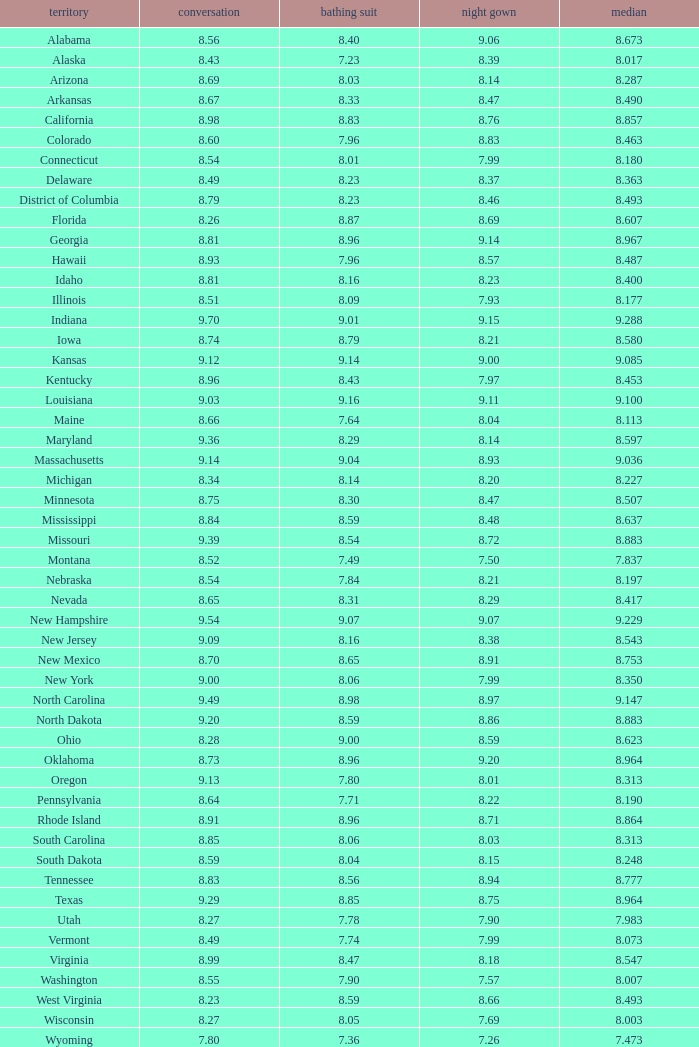Could you parse the entire table as a dict? {'header': ['territory', 'conversation', 'bathing suit', 'night gown', 'median'], 'rows': [['Alabama', '8.56', '8.40', '9.06', '8.673'], ['Alaska', '8.43', '7.23', '8.39', '8.017'], ['Arizona', '8.69', '8.03', '8.14', '8.287'], ['Arkansas', '8.67', '8.33', '8.47', '8.490'], ['California', '8.98', '8.83', '8.76', '8.857'], ['Colorado', '8.60', '7.96', '8.83', '8.463'], ['Connecticut', '8.54', '8.01', '7.99', '8.180'], ['Delaware', '8.49', '8.23', '8.37', '8.363'], ['District of Columbia', '8.79', '8.23', '8.46', '8.493'], ['Florida', '8.26', '8.87', '8.69', '8.607'], ['Georgia', '8.81', '8.96', '9.14', '8.967'], ['Hawaii', '8.93', '7.96', '8.57', '8.487'], ['Idaho', '8.81', '8.16', '8.23', '8.400'], ['Illinois', '8.51', '8.09', '7.93', '8.177'], ['Indiana', '9.70', '9.01', '9.15', '9.288'], ['Iowa', '8.74', '8.79', '8.21', '8.580'], ['Kansas', '9.12', '9.14', '9.00', '9.085'], ['Kentucky', '8.96', '8.43', '7.97', '8.453'], ['Louisiana', '9.03', '9.16', '9.11', '9.100'], ['Maine', '8.66', '7.64', '8.04', '8.113'], ['Maryland', '9.36', '8.29', '8.14', '8.597'], ['Massachusetts', '9.14', '9.04', '8.93', '9.036'], ['Michigan', '8.34', '8.14', '8.20', '8.227'], ['Minnesota', '8.75', '8.30', '8.47', '8.507'], ['Mississippi', '8.84', '8.59', '8.48', '8.637'], ['Missouri', '9.39', '8.54', '8.72', '8.883'], ['Montana', '8.52', '7.49', '7.50', '7.837'], ['Nebraska', '8.54', '7.84', '8.21', '8.197'], ['Nevada', '8.65', '8.31', '8.29', '8.417'], ['New Hampshire', '9.54', '9.07', '9.07', '9.229'], ['New Jersey', '9.09', '8.16', '8.38', '8.543'], ['New Mexico', '8.70', '8.65', '8.91', '8.753'], ['New York', '9.00', '8.06', '7.99', '8.350'], ['North Carolina', '9.49', '8.98', '8.97', '9.147'], ['North Dakota', '9.20', '8.59', '8.86', '8.883'], ['Ohio', '8.28', '9.00', '8.59', '8.623'], ['Oklahoma', '8.73', '8.96', '9.20', '8.964'], ['Oregon', '9.13', '7.80', '8.01', '8.313'], ['Pennsylvania', '8.64', '7.71', '8.22', '8.190'], ['Rhode Island', '8.91', '8.96', '8.71', '8.864'], ['South Carolina', '8.85', '8.06', '8.03', '8.313'], ['South Dakota', '8.59', '8.04', '8.15', '8.248'], ['Tennessee', '8.83', '8.56', '8.94', '8.777'], ['Texas', '9.29', '8.85', '8.75', '8.964'], ['Utah', '8.27', '7.78', '7.90', '7.983'], ['Vermont', '8.49', '7.74', '7.99', '8.073'], ['Virginia', '8.99', '8.47', '8.18', '8.547'], ['Washington', '8.55', '7.90', '7.57', '8.007'], ['West Virginia', '8.23', '8.59', '8.66', '8.493'], ['Wisconsin', '8.27', '8.05', '7.69', '8.003'], ['Wyoming', '7.80', '7.36', '7.26', '7.473']]} Tell me the sum of interview for evening gown more than 8.37 and average of 8.363 None. 